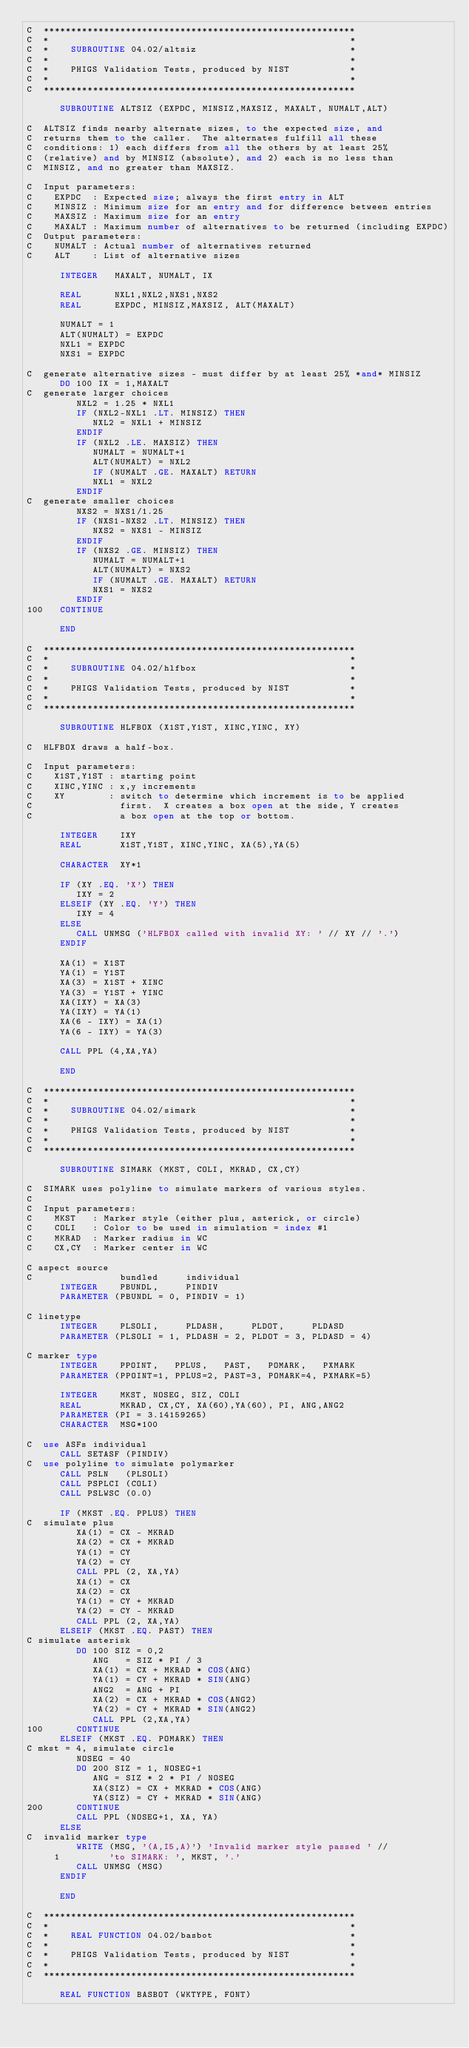<code> <loc_0><loc_0><loc_500><loc_500><_FORTRAN_>C  *********************************************************
C  *                                                       *
C  *    SUBROUTINE 04.02/altsiz                            *
C  *                                                       *
C  *    PHIGS Validation Tests, produced by NIST           *
C  *                                                       *
C  *********************************************************

      SUBROUTINE ALTSIZ (EXPDC, MINSIZ,MAXSIZ, MAXALT, NUMALT,ALT)

C  ALTSIZ finds nearby alternate sizes, to the expected size, and
C  returns them to the caller.  The alternates fulfill all these
C  conditions: 1) each differs from all the others by at least 25%
C  (relative) and by MINSIZ (absolute), and 2) each is no less than
C  MINSIZ, and no greater than MAXSIZ.

C  Input parameters:
C    EXPDC  : Expected size; always the first entry in ALT
C    MINSIZ : Minimum size for an entry and for difference between entries
C    MAXSIZ : Maximum size for an entry
C    MAXALT : Maximum number of alternatives to be returned (including EXPDC)
C  Output parameters:
C    NUMALT : Actual number of alternatives returned
C    ALT    : List of alternative sizes

      INTEGER   MAXALT, NUMALT, IX

      REAL      NXL1,NXL2,NXS1,NXS2
      REAL      EXPDC, MINSIZ,MAXSIZ, ALT(MAXALT)

      NUMALT = 1
      ALT(NUMALT) = EXPDC
      NXL1 = EXPDC
      NXS1 = EXPDC

C  generate alternative sizes - must differ by at least 25% *and* MINSIZ
      DO 100 IX = 1,MAXALT
C  generate larger choices
         NXL2 = 1.25 * NXL1
         IF (NXL2-NXL1 .LT. MINSIZ) THEN
            NXL2 = NXL1 + MINSIZ
         ENDIF
         IF (NXL2 .LE. MAXSIZ) THEN
            NUMALT = NUMALT+1
            ALT(NUMALT) = NXL2
            IF (NUMALT .GE. MAXALT) RETURN
            NXL1 = NXL2
         ENDIF
C  generate smaller choices
         NXS2 = NXS1/1.25
         IF (NXS1-NXS2 .LT. MINSIZ) THEN
            NXS2 = NXS1 - MINSIZ
         ENDIF
         IF (NXS2 .GE. MINSIZ) THEN
            NUMALT = NUMALT+1
            ALT(NUMALT) = NXS2
            IF (NUMALT .GE. MAXALT) RETURN
            NXS1 = NXS2
         ENDIF
100   CONTINUE

      END

C  *********************************************************
C  *                                                       *
C  *    SUBROUTINE 04.02/hlfbox                            *
C  *                                                       *
C  *    PHIGS Validation Tests, produced by NIST           *
C  *                                                       *
C  *********************************************************

      SUBROUTINE HLFBOX (X1ST,Y1ST, XINC,YINC, XY)

C  HLFBOX draws a half-box.

C  Input parameters:
C    X1ST,Y1ST : starting point
C    XINC,YINC : x,y increments
C    XY        : switch to determine which increment is to be applied
C                first.  X creates a box open at the side, Y creates
C                a box open at the top or bottom.

      INTEGER    IXY
      REAL       X1ST,Y1ST, XINC,YINC, XA(5),YA(5)

      CHARACTER  XY*1

      IF (XY .EQ. 'X') THEN
         IXY = 2
      ELSEIF (XY .EQ. 'Y') THEN
         IXY = 4
      ELSE
         CALL UNMSG ('HLFBOX called with invalid XY: ' // XY // '.') 
      ENDIF

      XA(1) = X1ST
      YA(1) = Y1ST
      XA(3) = X1ST + XINC
      YA(3) = Y1ST + YINC
      XA(IXY) = XA(3)
      YA(IXY) = YA(1)
      XA(6 - IXY) = XA(1)
      YA(6 - IXY) = YA(3)

      CALL PPL (4,XA,YA)

      END

C  *********************************************************
C  *                                                       *
C  *    SUBROUTINE 04.02/simark                            *
C  *                                                       *
C  *    PHIGS Validation Tests, produced by NIST           *
C  *                                                       *
C  *********************************************************

      SUBROUTINE SIMARK (MKST, COLI, MKRAD, CX,CY)

C  SIMARK uses polyline to simulate markers of various styles.
C
C  Input parameters:
C    MKST   : Marker style (either plus, asterick, or circle)
C    COLI   : Color to be used in simulation = index #1
C    MKRAD  : Marker radius in WC
C    CX,CY  : Marker center in WC

C aspect source
C                bundled     individual
      INTEGER    PBUNDL,     PINDIV
      PARAMETER (PBUNDL = 0, PINDIV = 1)

C linetype
      INTEGER    PLSOLI,     PLDASH,     PLDOT,     PLDASD
      PARAMETER (PLSOLI = 1, PLDASH = 2, PLDOT = 3, PLDASD = 4)

C marker type
      INTEGER    PPOINT,   PPLUS,   PAST,   POMARK,   PXMARK
      PARAMETER (PPOINT=1, PPLUS=2, PAST=3, POMARK=4, PXMARK=5)

      INTEGER    MKST, NOSEG, SIZ, COLI
      REAL       MKRAD, CX,CY, XA(60),YA(60), PI, ANG,ANG2
      PARAMETER (PI = 3.14159265)
      CHARACTER  MSG*100

C  use ASFs individual 
      CALL SETASF (PINDIV) 
C  use polyline to simulate polymarker 
      CALL PSLN   (PLSOLI)
      CALL PSPLCI (COLI)
      CALL PSLWSC (0.0)

      IF (MKST .EQ. PPLUS) THEN
C  simulate plus
         XA(1) = CX - MKRAD
         XA(2) = CX + MKRAD
         YA(1) = CY
         YA(2) = CY
         CALL PPL (2, XA,YA)
         XA(1) = CX
         XA(2) = CX
         YA(1) = CY + MKRAD
         YA(2) = CY - MKRAD
         CALL PPL (2, XA,YA)
      ELSEIF (MKST .EQ. PAST) THEN
C simulate asterisk
         DO 100 SIZ = 0,2
            ANG   = SIZ * PI / 3
            XA(1) = CX + MKRAD * COS(ANG)
            YA(1) = CY + MKRAD * SIN(ANG)
            ANG2  = ANG + PI
            XA(2) = CX + MKRAD * COS(ANG2)
            YA(2) = CY + MKRAD * SIN(ANG2)
            CALL PPL (2,XA,YA)
100      CONTINUE
      ELSEIF (MKST .EQ. POMARK) THEN
C mkst = 4, simulate circle
         NOSEG = 40
         DO 200 SIZ = 1, NOSEG+1
            ANG = SIZ * 2 * PI / NOSEG
            XA(SIZ) = CX + MKRAD * COS(ANG)
            YA(SIZ) = CY + MKRAD * SIN(ANG)
200      CONTINUE
         CALL PPL (NOSEG+1, XA, YA)
      ELSE
C  invalid marker type
         WRITE (MSG, '(A,I5,A)') 'Invalid marker style passed ' //
     1         'to SIMARK: ', MKST, '.'
         CALL UNMSG (MSG)
      ENDIF

      END

C  *********************************************************
C  *                                                       *
C  *    REAL FUNCTION 04.02/basbot                         *
C  *                                                       *
C  *    PHIGS Validation Tests, produced by NIST           *
C  *                                                       *
C  *********************************************************

      REAL FUNCTION BASBOT (WKTYPE, FONT)
</code> 